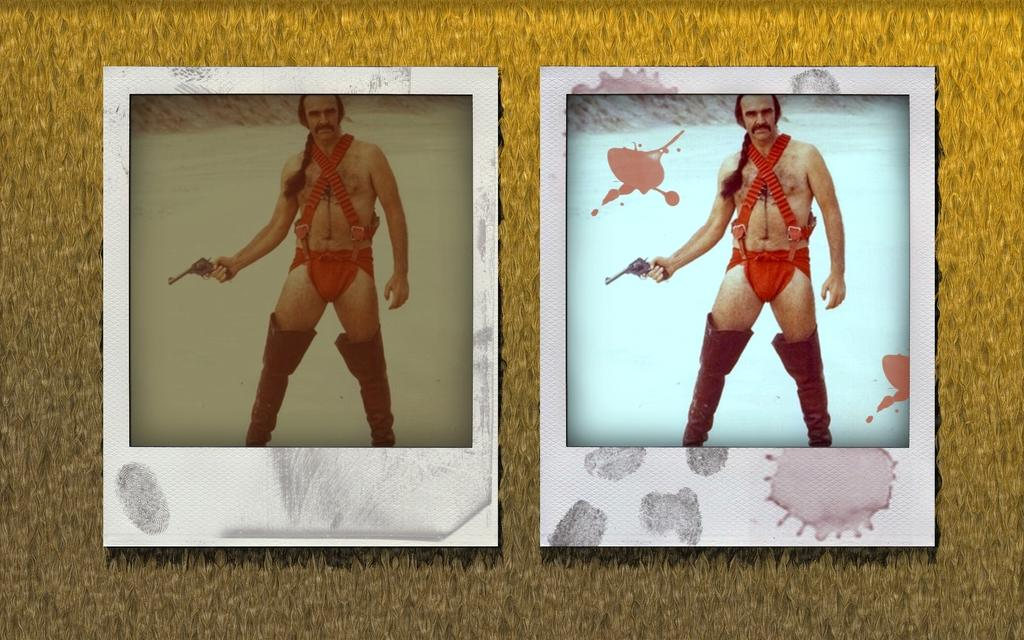What is the main subject of the image? The main subject of the image is two edited pictures of the same person. What is the person in the pictures doing with his left hand? The person is holding a gun in his left hand. What time is displayed on the clock in the image? There is no clock present in the image. How is the person measuring the distance between the two pictures in the image? There is no measuring or distance being discussed in the image; the person is simply holding a gun in his left hand. 